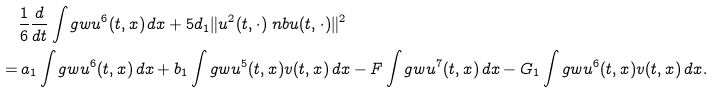<formula> <loc_0><loc_0><loc_500><loc_500>& \frac { 1 } { 6 } \frac { d } { d t } \int _ { \ } g w u ^ { 6 } ( t , x ) \, d x + 5 d _ { 1 } \| u ^ { 2 } ( t , \cdot ) \ n b u ( t , \cdot ) \| ^ { 2 } \\ = & \, a _ { 1 } \int _ { \ } g w u ^ { 6 } ( t , x ) \, d x + b _ { 1 } \int _ { \ } g w u ^ { 5 } ( t , x ) v ( t , x ) \, d x - F \int _ { \ } g w u ^ { 7 } ( t , x ) \, d x - G _ { 1 } \int _ { \ } g w u ^ { 6 } ( t , x ) v ( t , x ) \, d x .</formula> 